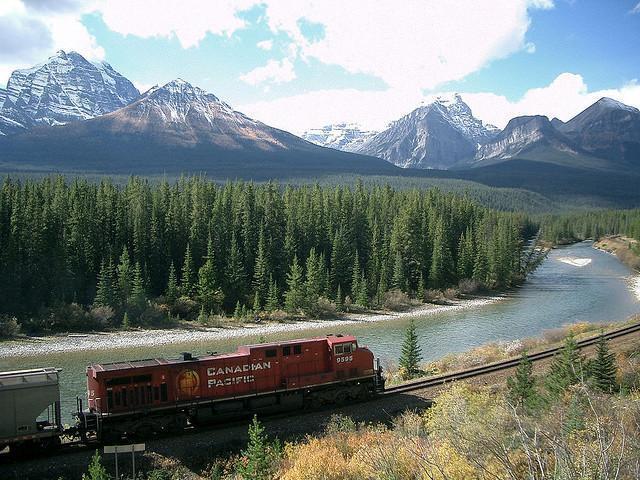How many people are in the photo?
Give a very brief answer. 0. 